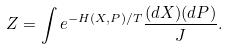<formula> <loc_0><loc_0><loc_500><loc_500>Z = \int e ^ { - H ( X , P ) / T } \frac { ( d X ) ( d P ) } J .</formula> 